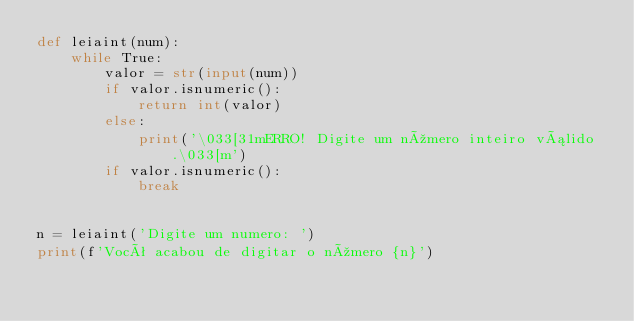Convert code to text. <code><loc_0><loc_0><loc_500><loc_500><_Python_>def leiaint(num):
    while True:
        valor = str(input(num))
        if valor.isnumeric():
            return int(valor)
        else:
            print('\033[31mERRO! Digite um número inteiro válido.\033[m')
        if valor.isnumeric():
            break


n = leiaint('Digite um numero: ')
print(f'Você acabou de digitar o número {n}')
</code> 